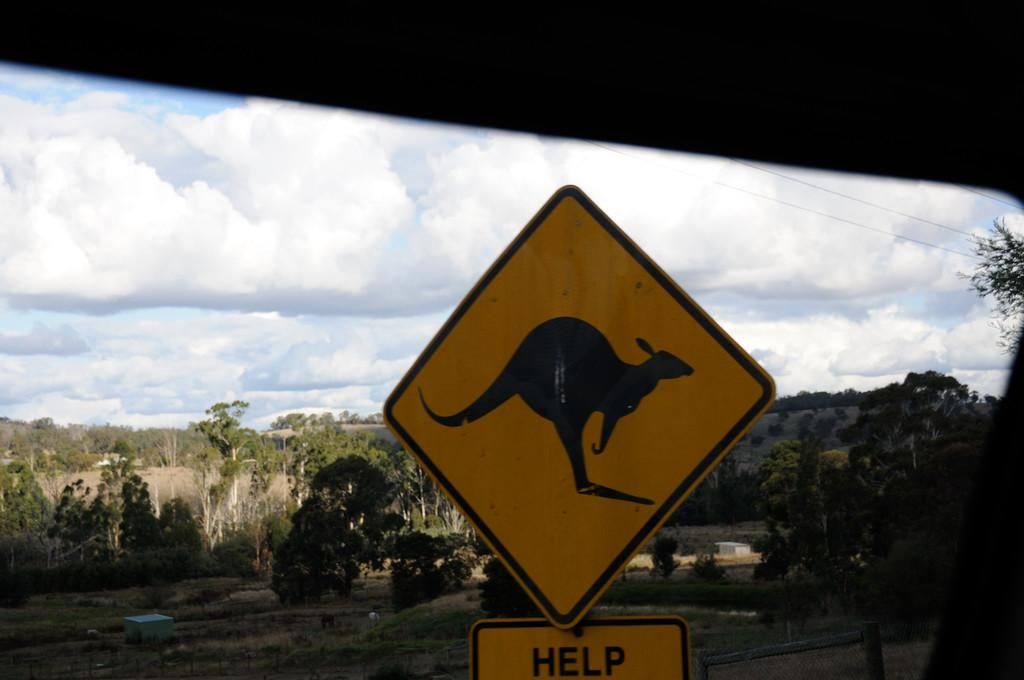<image>
Write a terse but informative summary of the picture. A diamond shaped road sign with a picture of a kangaroo reading Help underneath it 